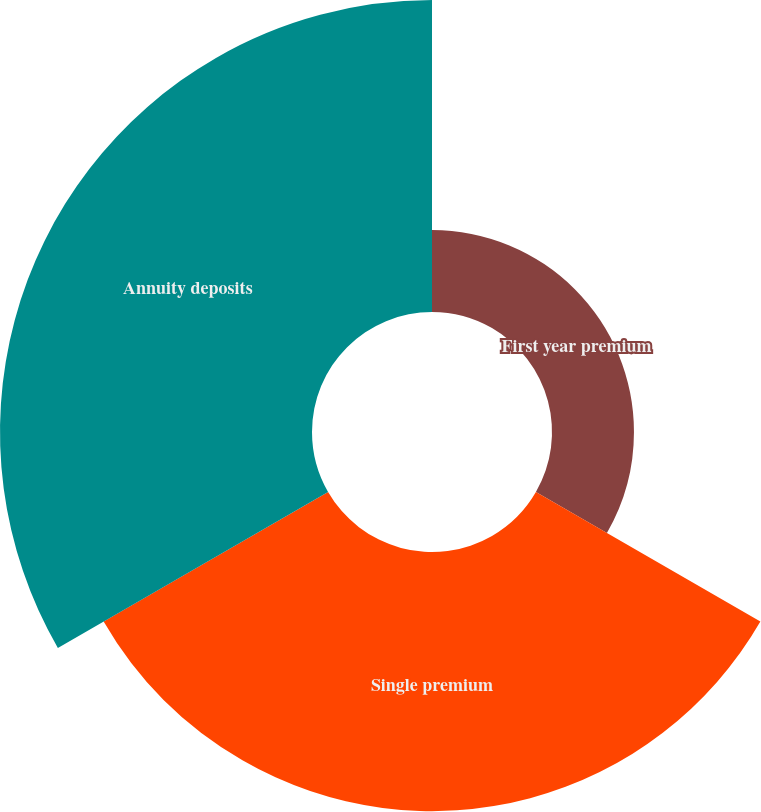Convert chart to OTSL. <chart><loc_0><loc_0><loc_500><loc_500><pie_chart><fcel>First year premium<fcel>Single premium<fcel>Annuity deposits<nl><fcel>12.55%<fcel>39.68%<fcel>47.77%<nl></chart> 